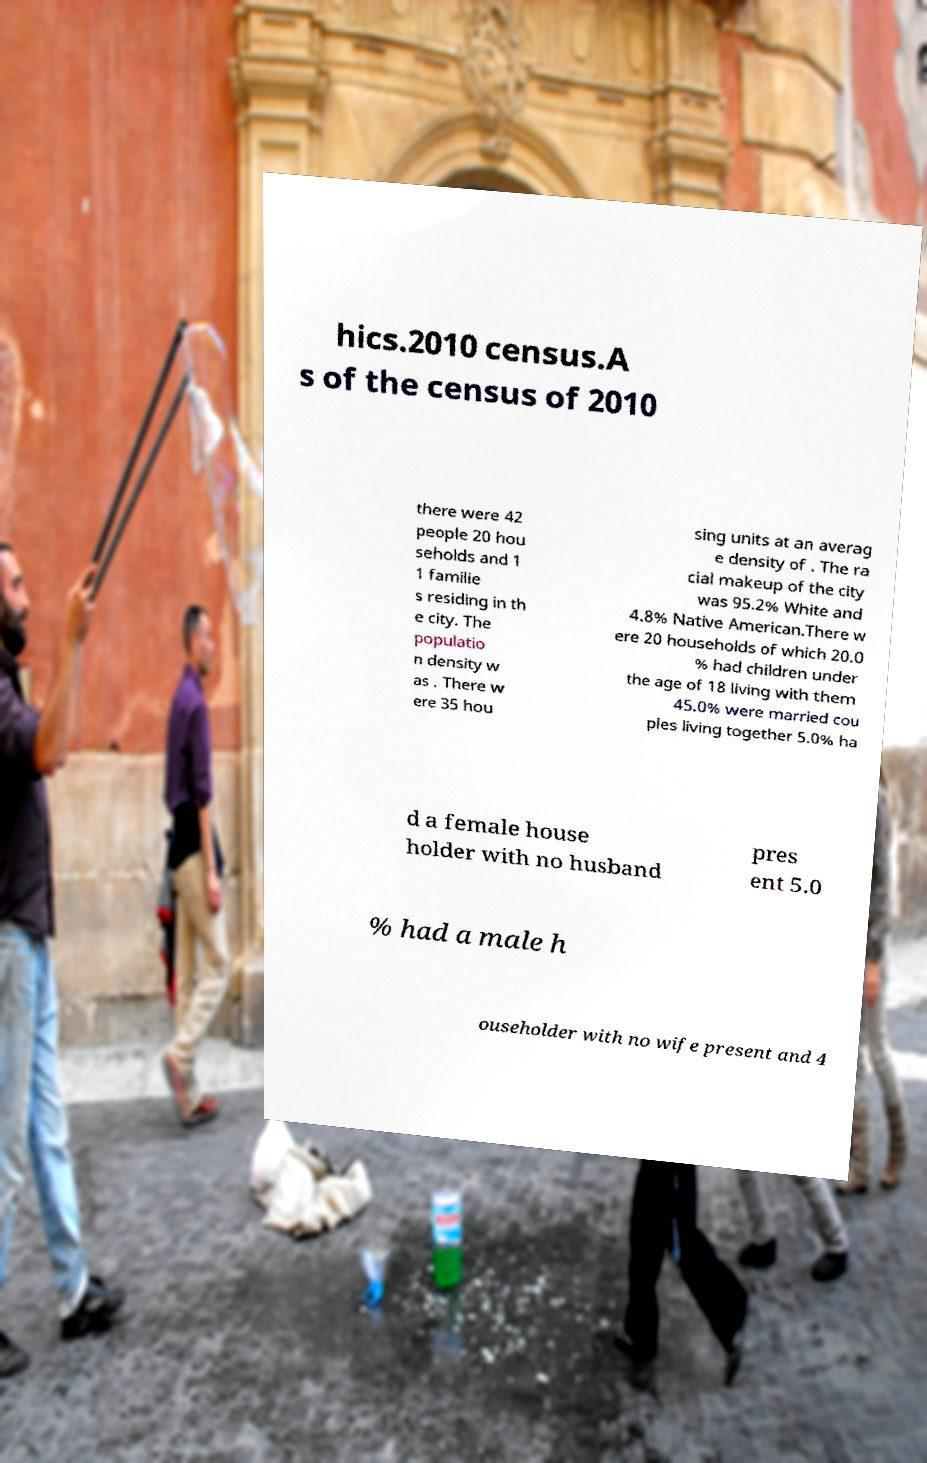For documentation purposes, I need the text within this image transcribed. Could you provide that? hics.2010 census.A s of the census of 2010 there were 42 people 20 hou seholds and 1 1 familie s residing in th e city. The populatio n density w as . There w ere 35 hou sing units at an averag e density of . The ra cial makeup of the city was 95.2% White and 4.8% Native American.There w ere 20 households of which 20.0 % had children under the age of 18 living with them 45.0% were married cou ples living together 5.0% ha d a female house holder with no husband pres ent 5.0 % had a male h ouseholder with no wife present and 4 